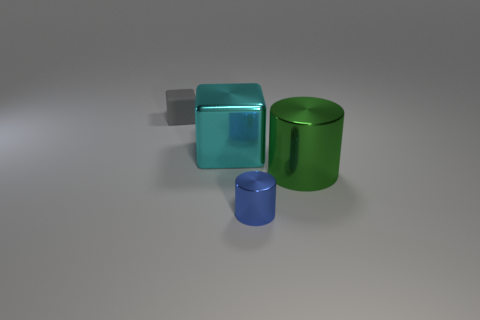What could be the purpose of these objects? It's difficult to ascertain the exact purpose without context, but they could be decorative, educational models for teaching geometry, or components of a larger mechanical system. If they were to be used educationally, what concepts might they teach? These objects could be used to teach geometric concepts such as volume, surface area, and the properties of different three-dimensional shapes. 